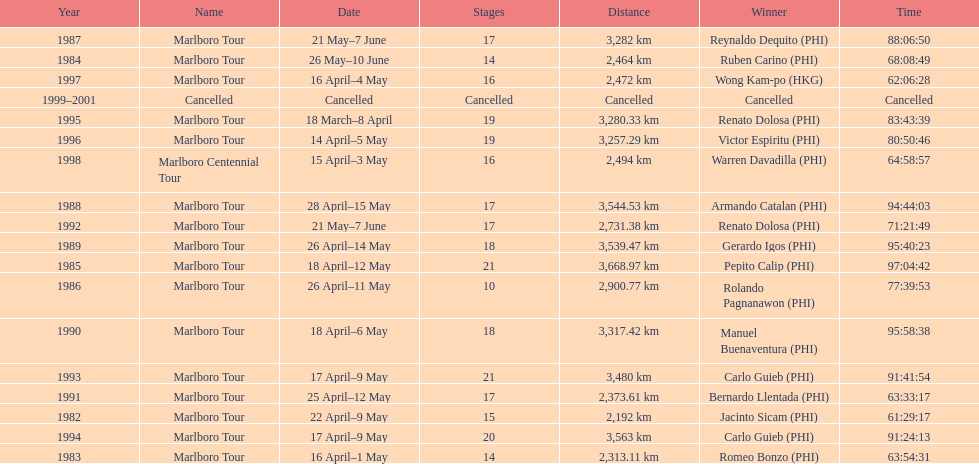How many marlboro tours did carlo guieb win? 2. 